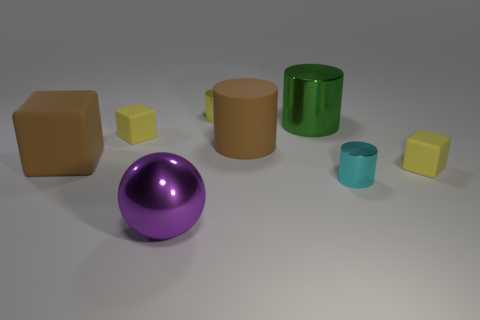How many other things are there of the same shape as the small cyan object?
Your answer should be very brief. 3. Does the cyan cylinder have the same material as the green object?
Make the answer very short. Yes. Is the number of brown blocks that are behind the tiny yellow cylinder the same as the number of large brown matte objects that are right of the brown rubber block?
Ensure brevity in your answer.  No. There is a small yellow thing that is the same shape as the cyan shiny thing; what is it made of?
Make the answer very short. Metal. The small yellow matte object left of the small yellow matte thing that is in front of the small yellow thing to the left of the big metallic sphere is what shape?
Ensure brevity in your answer.  Cube. Is the number of shiny cylinders in front of the tiny cyan object greater than the number of brown cylinders?
Keep it short and to the point. No. There is a yellow object to the left of the purple object; is its shape the same as the tiny yellow metal object?
Your answer should be compact. No. There is a tiny yellow block that is to the right of the green cylinder; what material is it?
Ensure brevity in your answer.  Rubber. What number of green metallic objects are the same shape as the tiny cyan metallic thing?
Offer a terse response. 1. There is a big cylinder behind the yellow cube that is on the left side of the large purple thing; what is it made of?
Give a very brief answer. Metal. 